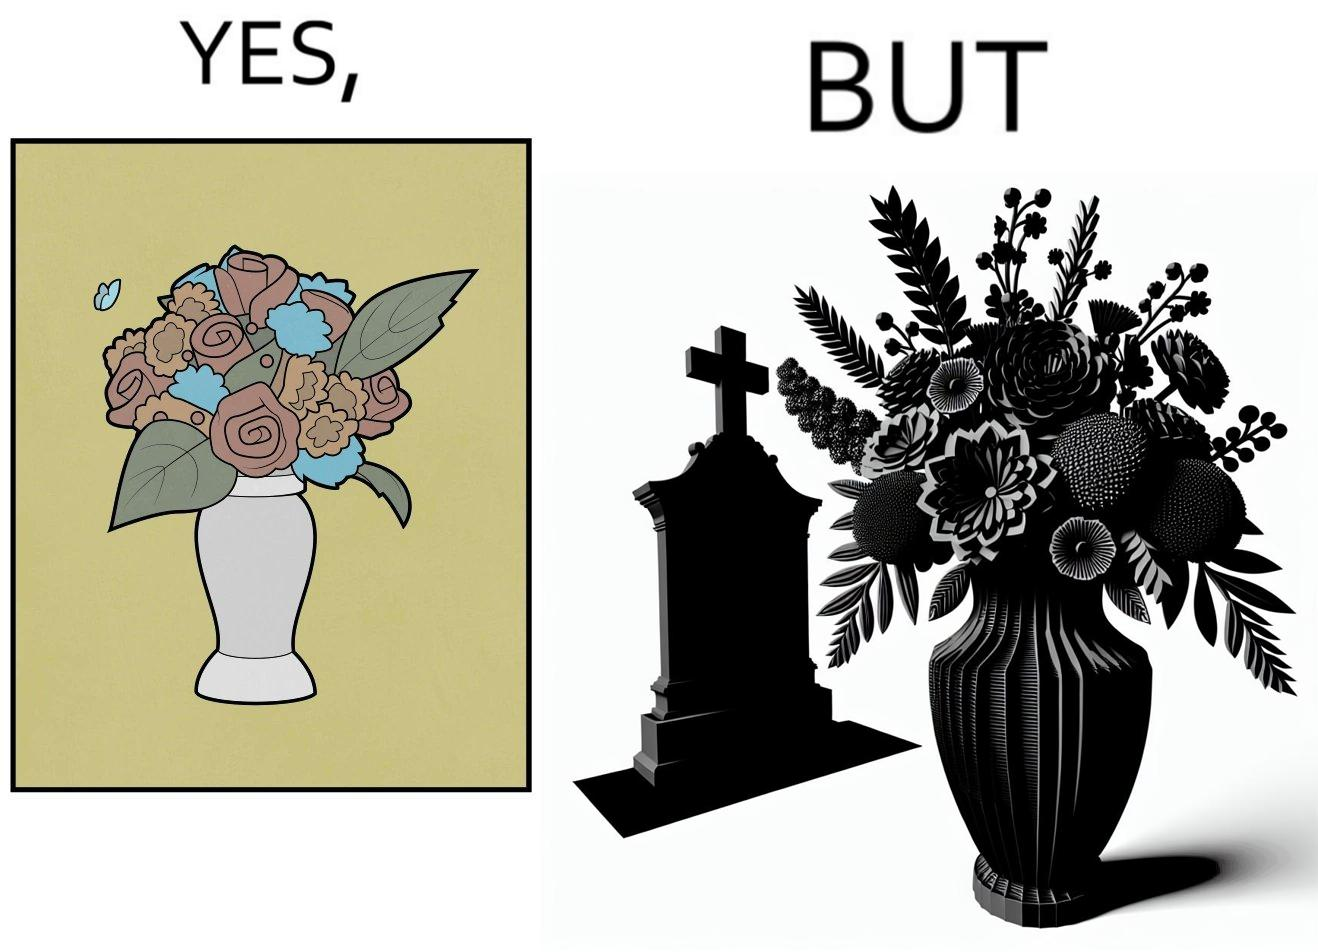Is this a satirical image? Yes, this image is satirical. 